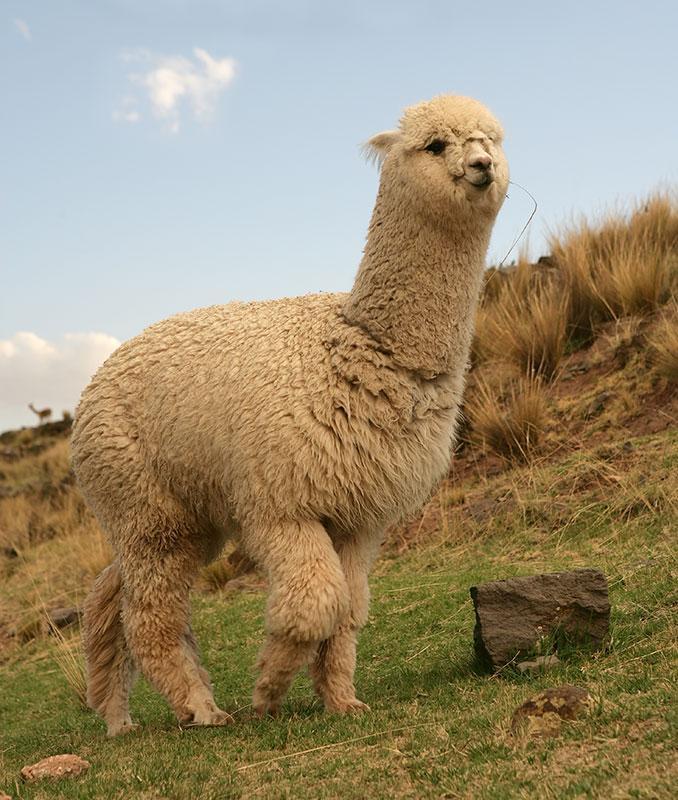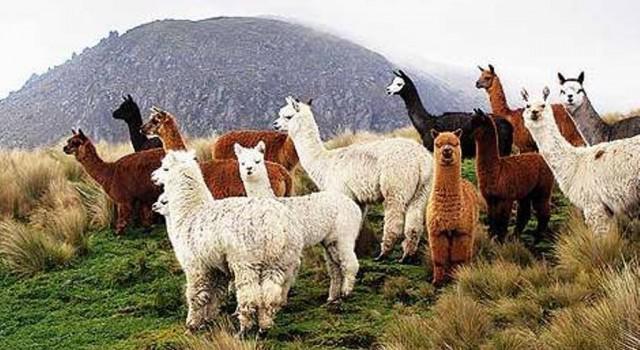The first image is the image on the left, the second image is the image on the right. Assess this claim about the two images: "The left image features exactly one light-colored llama, and the right image shows a group of at least nine llamas, most of them standing in profile.". Correct or not? Answer yes or no. Yes. The first image is the image on the left, the second image is the image on the right. Evaluate the accuracy of this statement regarding the images: "There is a single alpaca in one image and multiple ones in the other.". Is it true? Answer yes or no. Yes. 